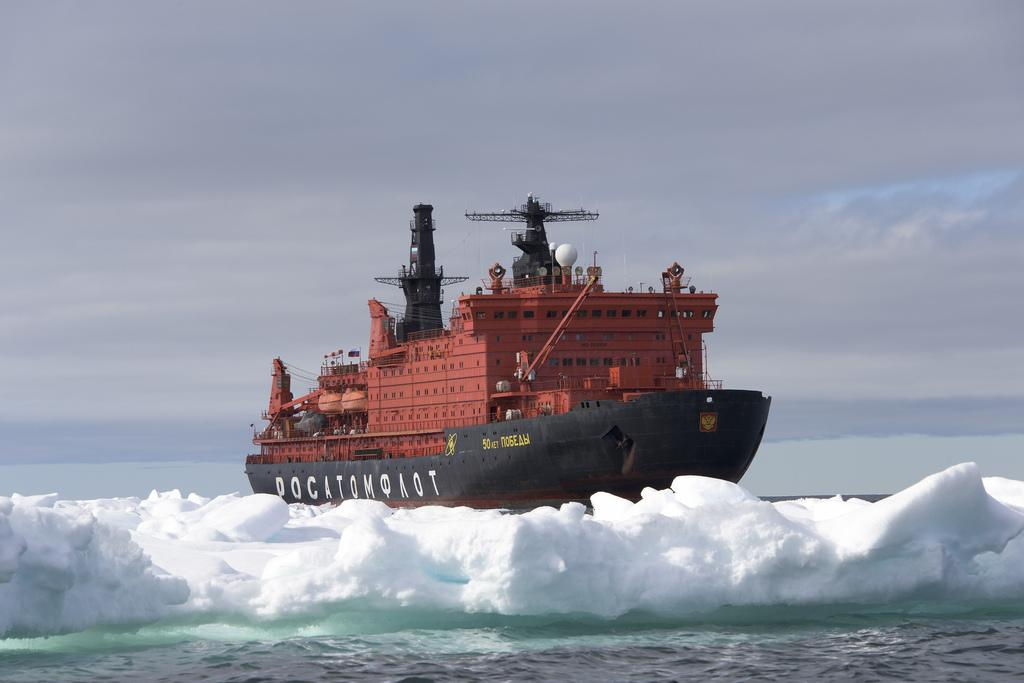What is the color of the ship in the image? The ship in the image is red. Where is the ship located? The ship is in an Ocean. What can be seen at the bottom of the image? There is ice on the water at the bottom of the image. What is visible at the top of the image? The sky is visible at the top of the image. What type of star is visible in the image? There is no star visible in the image; it only shows a red ship in an Ocean with ice at the bottom and the sky at the top. 